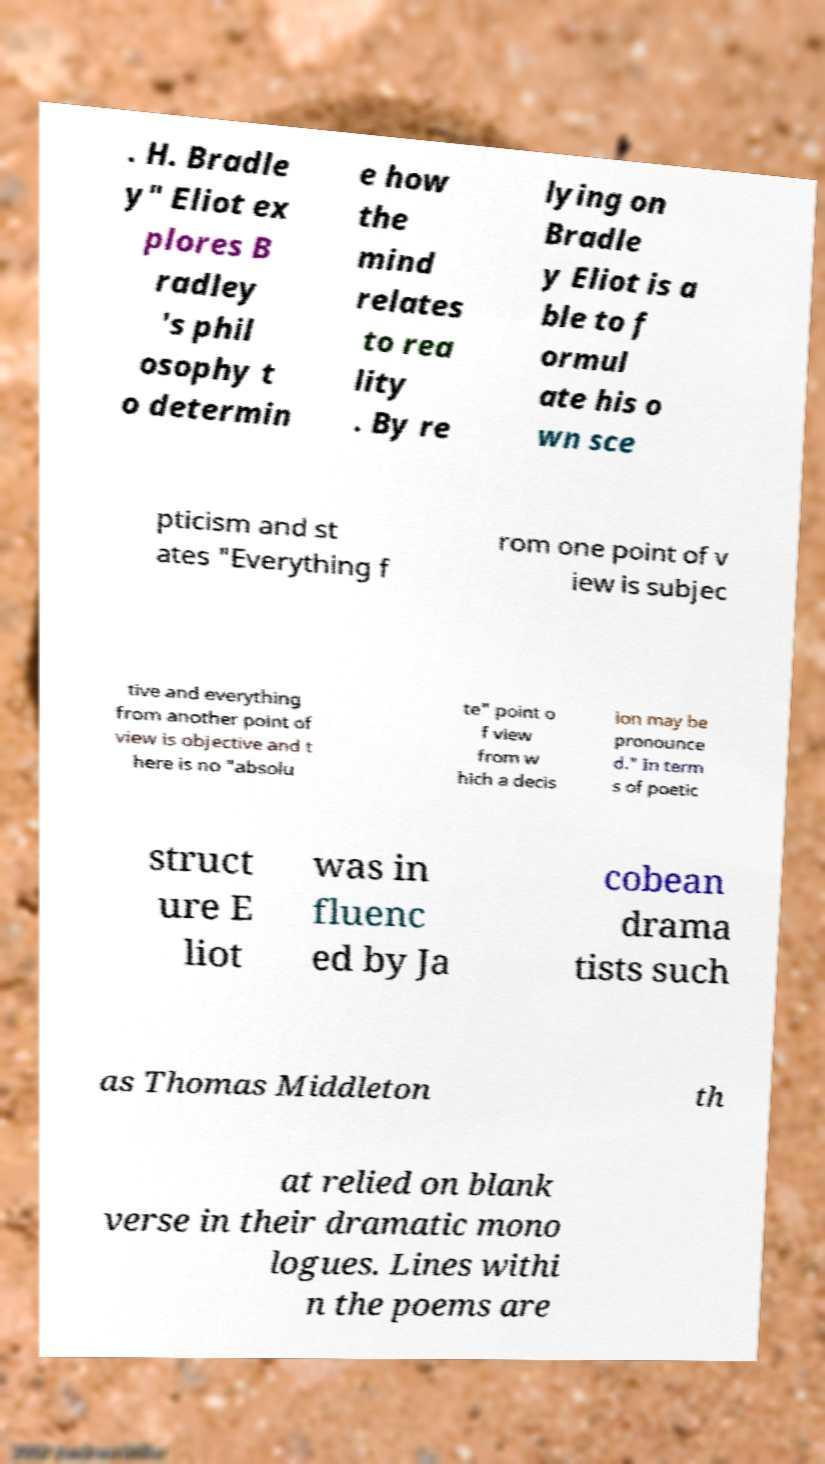Could you assist in decoding the text presented in this image and type it out clearly? . H. Bradle y" Eliot ex plores B radley 's phil osophy t o determin e how the mind relates to rea lity . By re lying on Bradle y Eliot is a ble to f ormul ate his o wn sce pticism and st ates "Everything f rom one point of v iew is subjec tive and everything from another point of view is objective and t here is no "absolu te" point o f view from w hich a decis ion may be pronounce d." In term s of poetic struct ure E liot was in fluenc ed by Ja cobean drama tists such as Thomas Middleton th at relied on blank verse in their dramatic mono logues. Lines withi n the poems are 